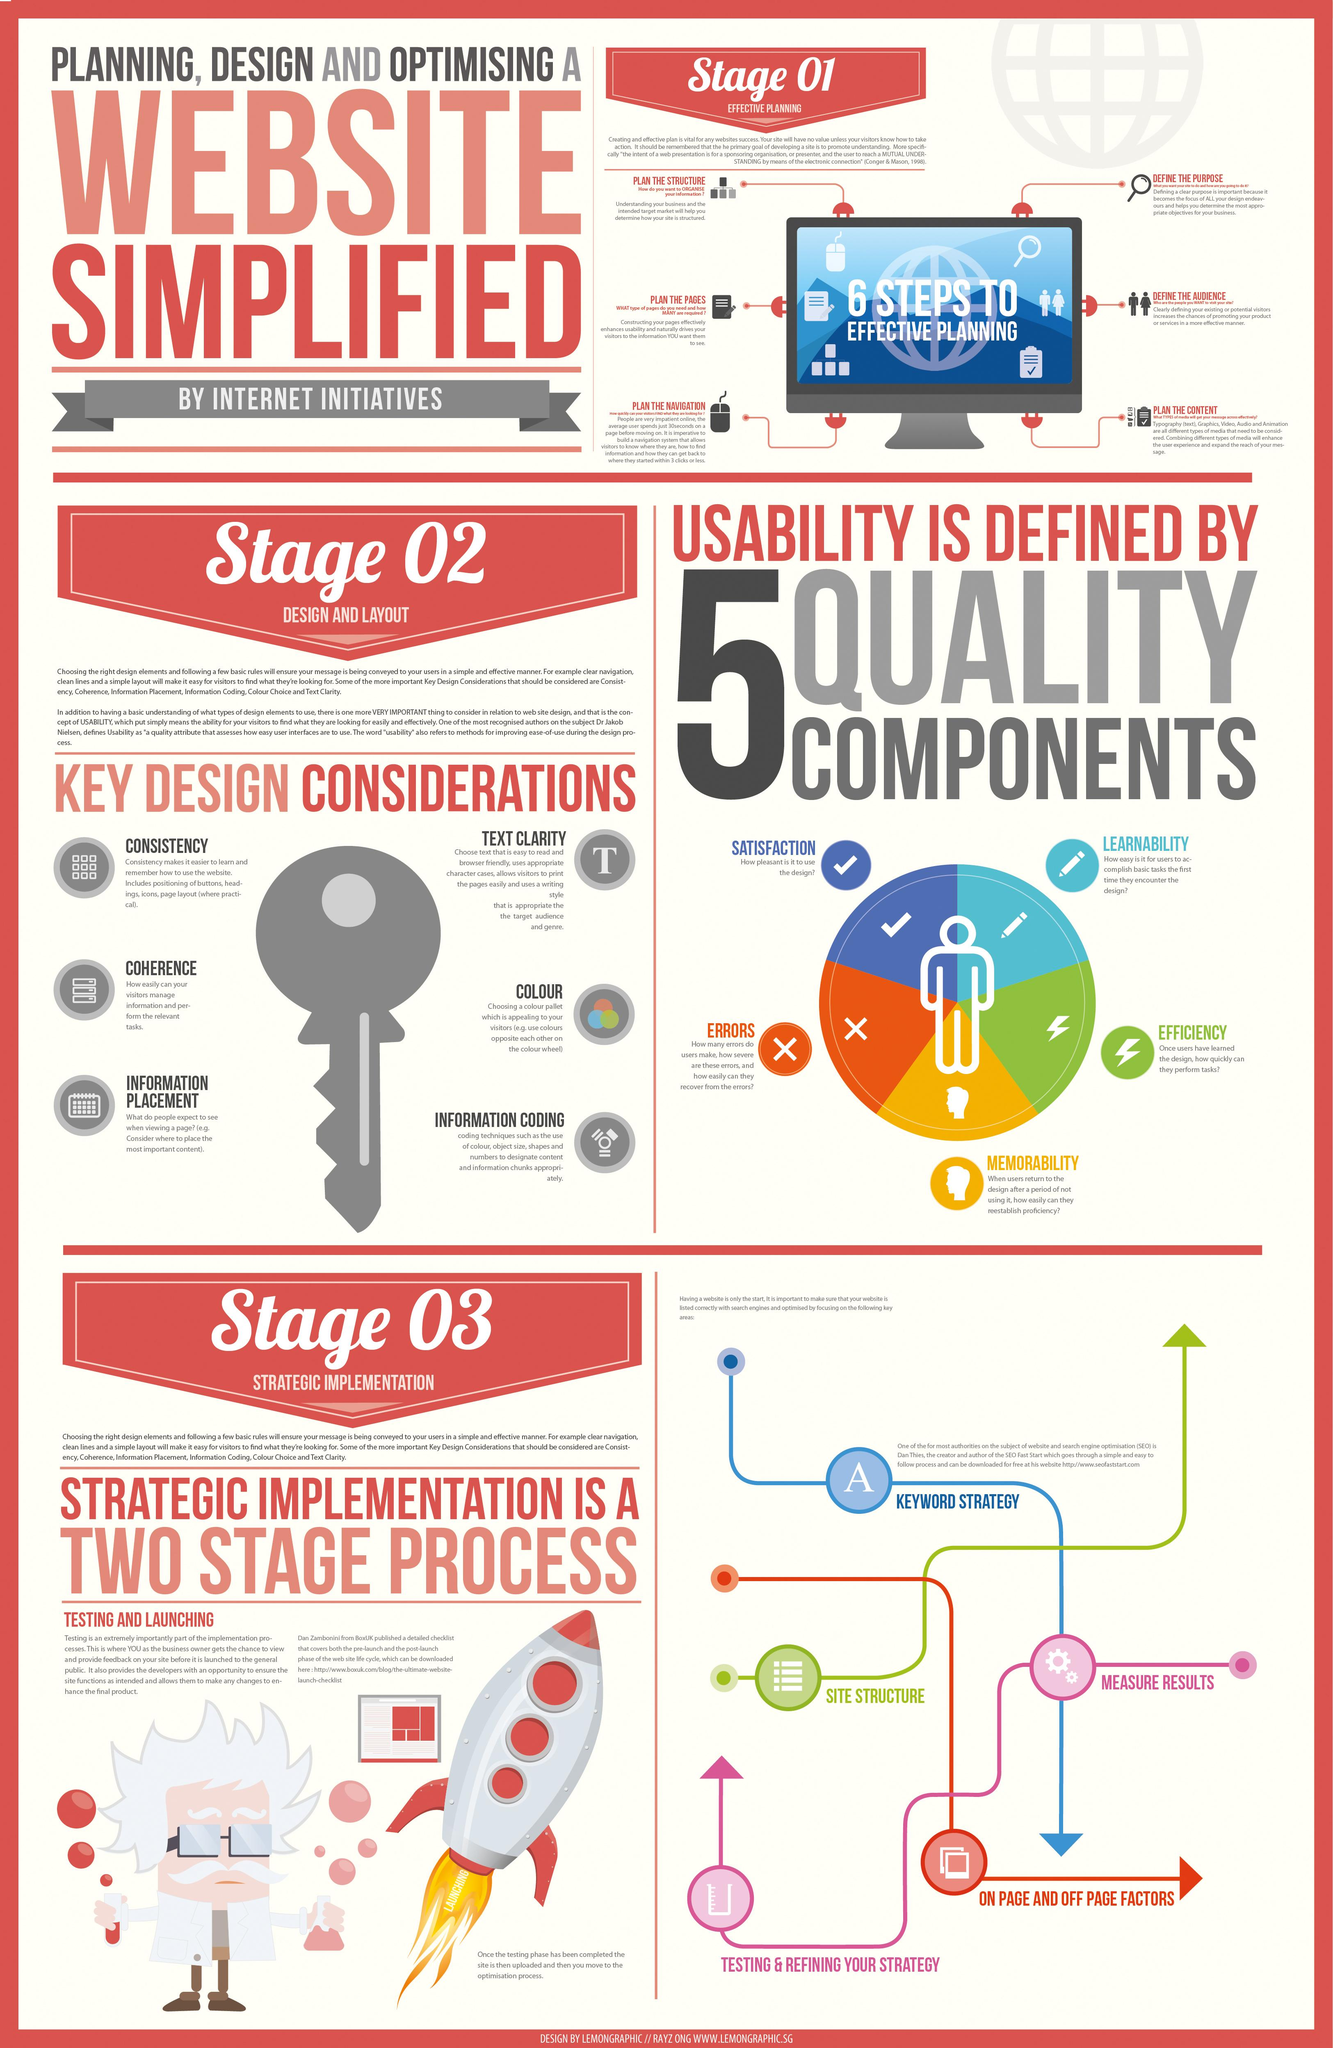Give some essential details in this illustration. Learnability, the quality component represented by an icon of a pen, is a critical factor in determining the effectiveness of a user interface. The color of the key is grey, and not white. The component displaying red quality is the error. There are six key design considerations to keep in mind when designing a system for a specific task. The key design consideration to enable visitors to manage information is coherence. 